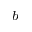Convert formula to latex. <formula><loc_0><loc_0><loc_500><loc_500>^ { b }</formula> 